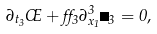<formula> <loc_0><loc_0><loc_500><loc_500>\partial _ { t _ { 3 } } \phi + \alpha _ { 3 } \partial _ { x _ { 1 } } ^ { 3 } \Pi _ { 3 } = 0 ,</formula> 